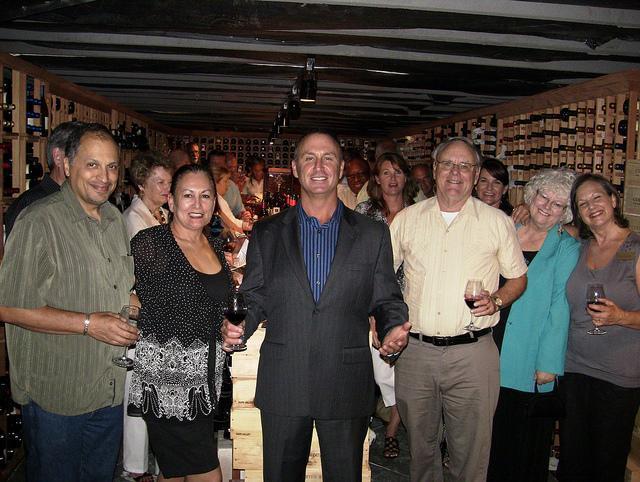How many people are there?
Give a very brief answer. 8. 